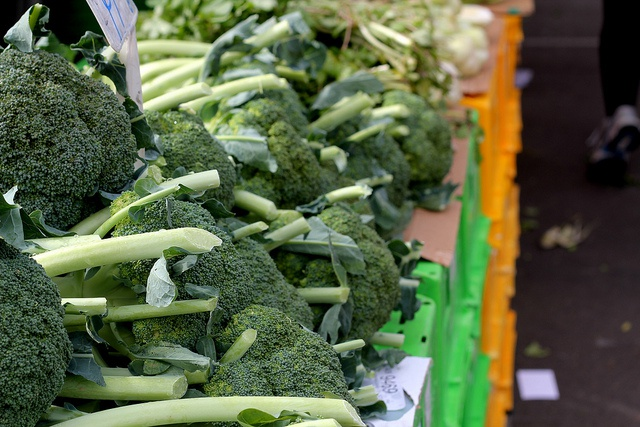Describe the objects in this image and their specific colors. I can see broccoli in black and darkgreen tones, broccoli in black, gray, and darkgreen tones, broccoli in black, darkgreen, and olive tones, broccoli in black, teal, and darkgreen tones, and broccoli in black and darkgreen tones in this image. 